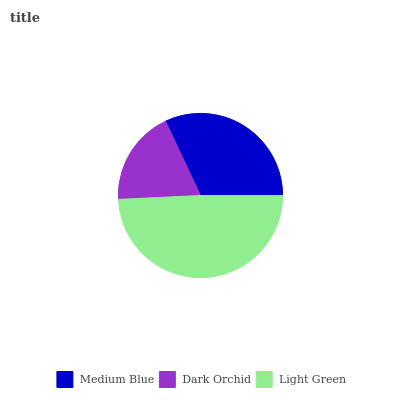Is Dark Orchid the minimum?
Answer yes or no. Yes. Is Light Green the maximum?
Answer yes or no. Yes. Is Light Green the minimum?
Answer yes or no. No. Is Dark Orchid the maximum?
Answer yes or no. No. Is Light Green greater than Dark Orchid?
Answer yes or no. Yes. Is Dark Orchid less than Light Green?
Answer yes or no. Yes. Is Dark Orchid greater than Light Green?
Answer yes or no. No. Is Light Green less than Dark Orchid?
Answer yes or no. No. Is Medium Blue the high median?
Answer yes or no. Yes. Is Medium Blue the low median?
Answer yes or no. Yes. Is Light Green the high median?
Answer yes or no. No. Is Light Green the low median?
Answer yes or no. No. 